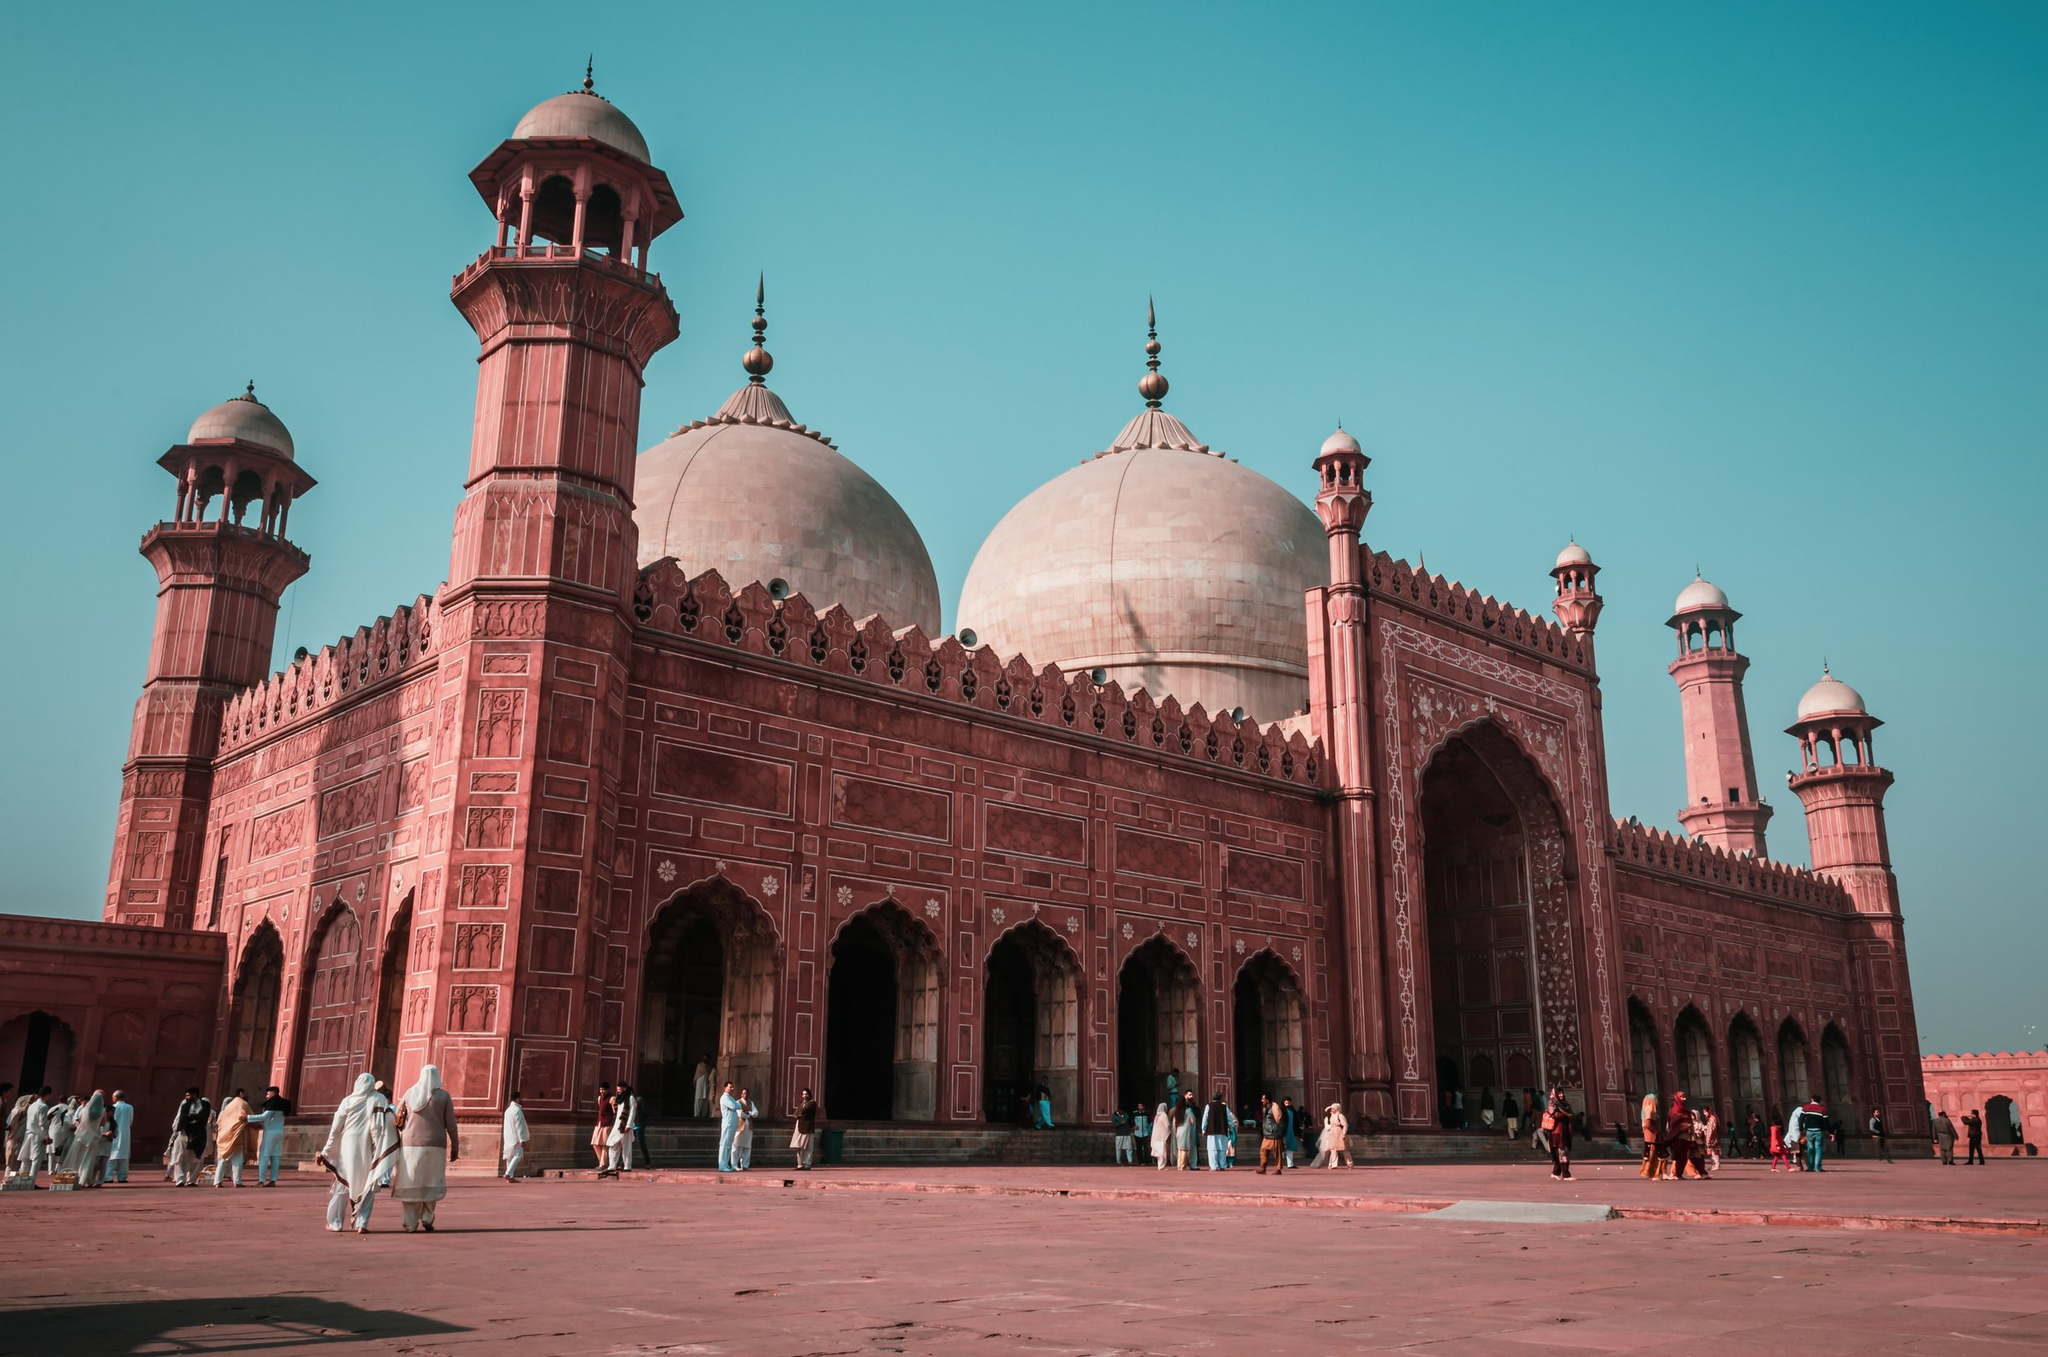Can you tell me more about the architecture of this mosque? Certainly! The Badshahi Mosque is a masterpiece of Mughal architecture, characteristic of its large domes, towering minarets, and the extensive use of red sandstone complemented by marble inlay. The mosque's design includes intricate geometric patterns, calligraphy, and detailed floral motifs that are hallmarks of Islamic art. Structurally, the mosque is an imposing structure with vast open spaces, designed to accommodate thousands of worshippers. The symmetry and balance in its construction reflect a blend of aesthetic appeal and spiritual symbolism. 